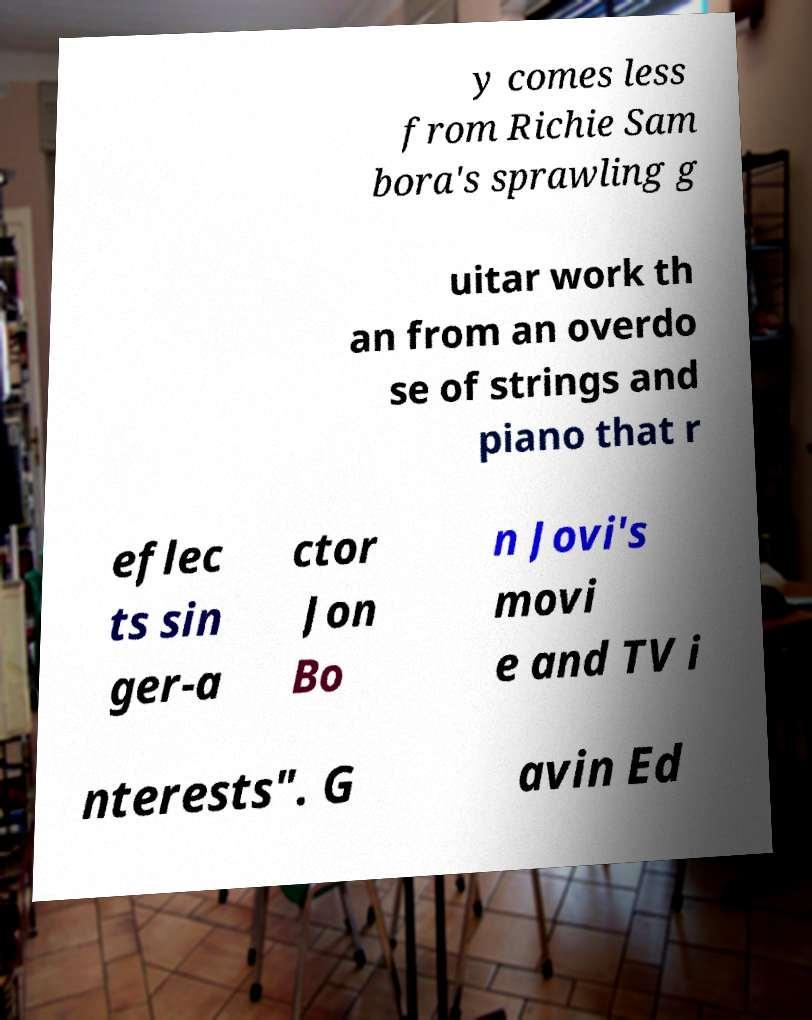What messages or text are displayed in this image? I need them in a readable, typed format. y comes less from Richie Sam bora's sprawling g uitar work th an from an overdo se of strings and piano that r eflec ts sin ger-a ctor Jon Bo n Jovi's movi e and TV i nterests". G avin Ed 